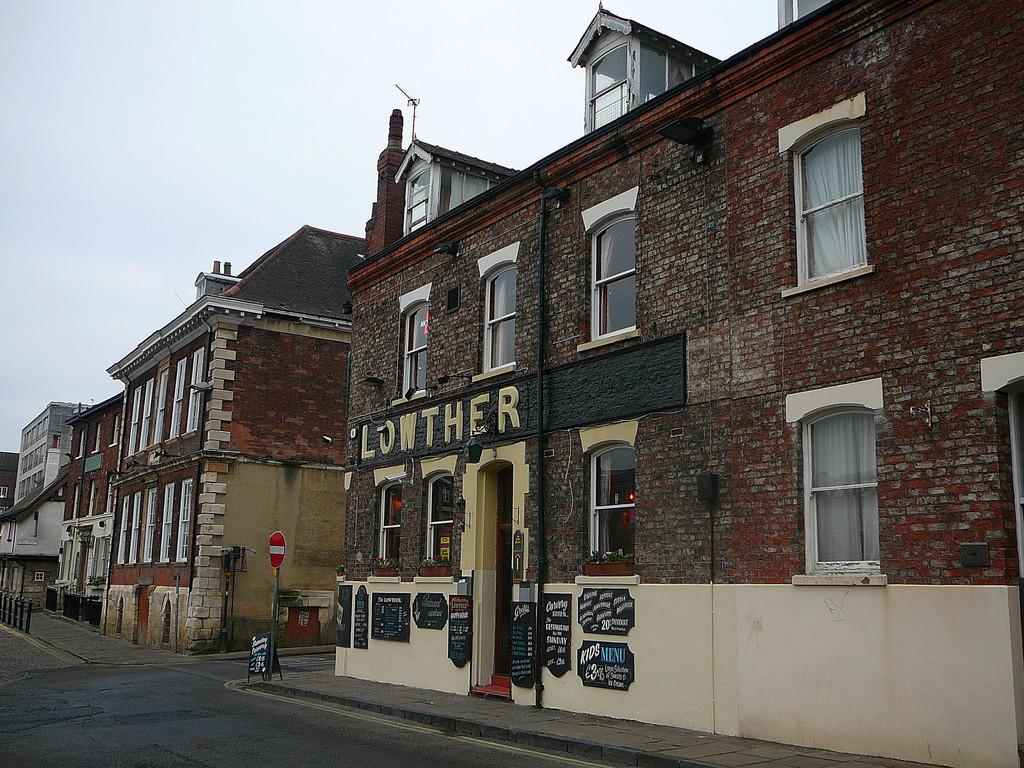What type of structures can be seen in the image? There are buildings in the image. What is written or depicted in the image? There is something written in the image. What can be seen in the image that people use for transportation? There is a road visible in the image. What type of information might be conveyed by the sign board in the image? The sign board in the image might convey information about directions, warnings, or advertisements. What is visible in the background of the image? The sky is clear and visible in the background of the image. Can you see any leaves falling from the trees in the image? There are no trees visible in the image, so it is not possible to see any leaves falling. Is there a stream running through the buildings in the image? There is no stream present in the image; it only features buildings, a road, a sign board, and the sky. 